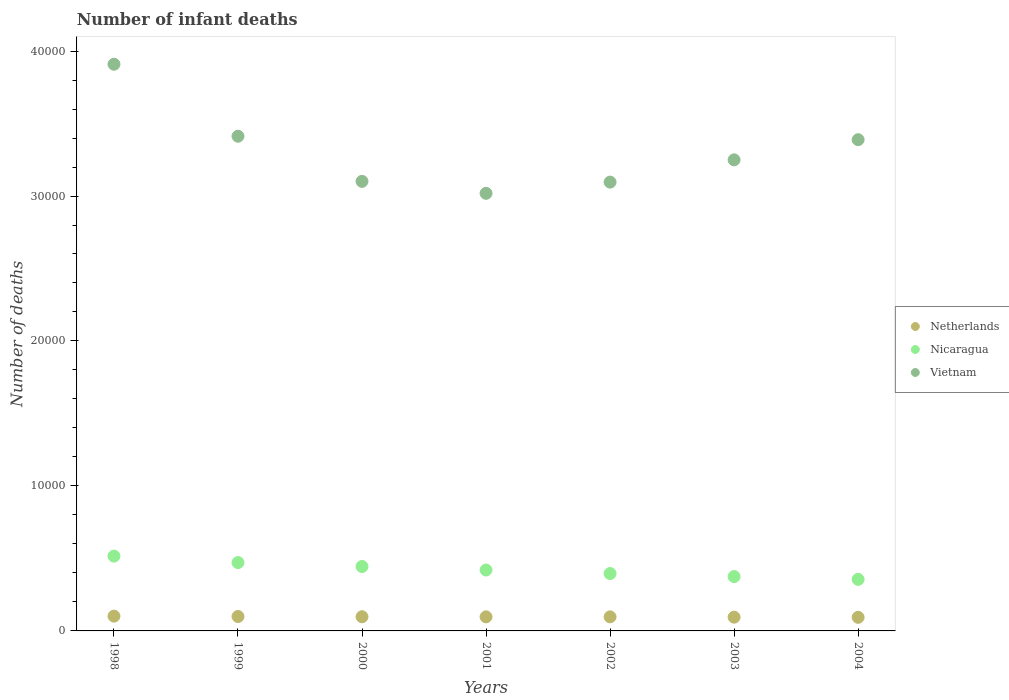How many different coloured dotlines are there?
Give a very brief answer. 3. Is the number of dotlines equal to the number of legend labels?
Your answer should be very brief. Yes. What is the number of infant deaths in Netherlands in 1998?
Your answer should be very brief. 1019. Across all years, what is the maximum number of infant deaths in Vietnam?
Provide a short and direct response. 3.91e+04. Across all years, what is the minimum number of infant deaths in Netherlands?
Offer a very short reply. 938. What is the total number of infant deaths in Nicaragua in the graph?
Your answer should be compact. 2.98e+04. What is the difference between the number of infant deaths in Vietnam in 2001 and that in 2003?
Give a very brief answer. -2308. What is the difference between the number of infant deaths in Netherlands in 1998 and the number of infant deaths in Nicaragua in 2004?
Make the answer very short. -2537. What is the average number of infant deaths in Netherlands per year?
Make the answer very short. 974.14. In the year 2002, what is the difference between the number of infant deaths in Vietnam and number of infant deaths in Nicaragua?
Your answer should be very brief. 2.70e+04. What is the ratio of the number of infant deaths in Nicaragua in 1998 to that in 2001?
Provide a short and direct response. 1.23. Is the number of infant deaths in Vietnam in 1999 less than that in 2003?
Your answer should be compact. No. What is the difference between the highest and the second highest number of infant deaths in Vietnam?
Offer a terse response. 4966. What is the difference between the highest and the lowest number of infant deaths in Vietnam?
Your answer should be very brief. 8904. Is the sum of the number of infant deaths in Nicaragua in 2001 and 2002 greater than the maximum number of infant deaths in Netherlands across all years?
Your response must be concise. Yes. Does the number of infant deaths in Vietnam monotonically increase over the years?
Your answer should be compact. No. Is the number of infant deaths in Nicaragua strictly less than the number of infant deaths in Vietnam over the years?
Make the answer very short. Yes. Are the values on the major ticks of Y-axis written in scientific E-notation?
Provide a succinct answer. No. Does the graph contain grids?
Make the answer very short. No. Where does the legend appear in the graph?
Make the answer very short. Center right. What is the title of the graph?
Provide a short and direct response. Number of infant deaths. What is the label or title of the X-axis?
Make the answer very short. Years. What is the label or title of the Y-axis?
Offer a terse response. Number of deaths. What is the Number of deaths of Netherlands in 1998?
Make the answer very short. 1019. What is the Number of deaths of Nicaragua in 1998?
Provide a short and direct response. 5161. What is the Number of deaths of Vietnam in 1998?
Your answer should be very brief. 3.91e+04. What is the Number of deaths of Netherlands in 1999?
Provide a succinct answer. 995. What is the Number of deaths of Nicaragua in 1999?
Keep it short and to the point. 4716. What is the Number of deaths in Vietnam in 1999?
Your answer should be very brief. 3.41e+04. What is the Number of deaths of Netherlands in 2000?
Your response must be concise. 978. What is the Number of deaths in Nicaragua in 2000?
Ensure brevity in your answer.  4444. What is the Number of deaths in Vietnam in 2000?
Keep it short and to the point. 3.10e+04. What is the Number of deaths of Netherlands in 2001?
Provide a succinct answer. 971. What is the Number of deaths in Nicaragua in 2001?
Provide a succinct answer. 4201. What is the Number of deaths in Vietnam in 2001?
Make the answer very short. 3.02e+04. What is the Number of deaths of Netherlands in 2002?
Your response must be concise. 970. What is the Number of deaths in Nicaragua in 2002?
Your answer should be compact. 3958. What is the Number of deaths of Vietnam in 2002?
Provide a succinct answer. 3.10e+04. What is the Number of deaths in Netherlands in 2003?
Offer a very short reply. 948. What is the Number of deaths of Nicaragua in 2003?
Offer a very short reply. 3749. What is the Number of deaths of Vietnam in 2003?
Your answer should be compact. 3.25e+04. What is the Number of deaths of Netherlands in 2004?
Provide a succinct answer. 938. What is the Number of deaths in Nicaragua in 2004?
Offer a very short reply. 3556. What is the Number of deaths in Vietnam in 2004?
Offer a very short reply. 3.39e+04. Across all years, what is the maximum Number of deaths in Netherlands?
Keep it short and to the point. 1019. Across all years, what is the maximum Number of deaths of Nicaragua?
Offer a terse response. 5161. Across all years, what is the maximum Number of deaths of Vietnam?
Your answer should be compact. 3.91e+04. Across all years, what is the minimum Number of deaths of Netherlands?
Provide a succinct answer. 938. Across all years, what is the minimum Number of deaths of Nicaragua?
Your answer should be compact. 3556. Across all years, what is the minimum Number of deaths of Vietnam?
Your response must be concise. 3.02e+04. What is the total Number of deaths in Netherlands in the graph?
Offer a terse response. 6819. What is the total Number of deaths in Nicaragua in the graph?
Provide a short and direct response. 2.98e+04. What is the total Number of deaths in Vietnam in the graph?
Give a very brief answer. 2.32e+05. What is the difference between the Number of deaths of Netherlands in 1998 and that in 1999?
Ensure brevity in your answer.  24. What is the difference between the Number of deaths in Nicaragua in 1998 and that in 1999?
Provide a succinct answer. 445. What is the difference between the Number of deaths of Vietnam in 1998 and that in 1999?
Keep it short and to the point. 4966. What is the difference between the Number of deaths of Netherlands in 1998 and that in 2000?
Keep it short and to the point. 41. What is the difference between the Number of deaths in Nicaragua in 1998 and that in 2000?
Make the answer very short. 717. What is the difference between the Number of deaths in Vietnam in 1998 and that in 2000?
Give a very brief answer. 8080. What is the difference between the Number of deaths of Netherlands in 1998 and that in 2001?
Offer a very short reply. 48. What is the difference between the Number of deaths of Nicaragua in 1998 and that in 2001?
Your answer should be compact. 960. What is the difference between the Number of deaths in Vietnam in 1998 and that in 2001?
Your response must be concise. 8904. What is the difference between the Number of deaths in Netherlands in 1998 and that in 2002?
Your response must be concise. 49. What is the difference between the Number of deaths in Nicaragua in 1998 and that in 2002?
Your response must be concise. 1203. What is the difference between the Number of deaths of Vietnam in 1998 and that in 2002?
Offer a very short reply. 8132. What is the difference between the Number of deaths in Nicaragua in 1998 and that in 2003?
Keep it short and to the point. 1412. What is the difference between the Number of deaths in Vietnam in 1998 and that in 2003?
Provide a succinct answer. 6596. What is the difference between the Number of deaths of Nicaragua in 1998 and that in 2004?
Provide a short and direct response. 1605. What is the difference between the Number of deaths of Vietnam in 1998 and that in 2004?
Your answer should be compact. 5205. What is the difference between the Number of deaths of Netherlands in 1999 and that in 2000?
Offer a terse response. 17. What is the difference between the Number of deaths in Nicaragua in 1999 and that in 2000?
Your answer should be compact. 272. What is the difference between the Number of deaths in Vietnam in 1999 and that in 2000?
Provide a short and direct response. 3114. What is the difference between the Number of deaths in Nicaragua in 1999 and that in 2001?
Your response must be concise. 515. What is the difference between the Number of deaths of Vietnam in 1999 and that in 2001?
Ensure brevity in your answer.  3938. What is the difference between the Number of deaths of Nicaragua in 1999 and that in 2002?
Provide a succinct answer. 758. What is the difference between the Number of deaths in Vietnam in 1999 and that in 2002?
Ensure brevity in your answer.  3166. What is the difference between the Number of deaths in Nicaragua in 1999 and that in 2003?
Provide a short and direct response. 967. What is the difference between the Number of deaths in Vietnam in 1999 and that in 2003?
Your response must be concise. 1630. What is the difference between the Number of deaths of Netherlands in 1999 and that in 2004?
Offer a very short reply. 57. What is the difference between the Number of deaths of Nicaragua in 1999 and that in 2004?
Your response must be concise. 1160. What is the difference between the Number of deaths of Vietnam in 1999 and that in 2004?
Your response must be concise. 239. What is the difference between the Number of deaths of Netherlands in 2000 and that in 2001?
Offer a terse response. 7. What is the difference between the Number of deaths of Nicaragua in 2000 and that in 2001?
Your answer should be very brief. 243. What is the difference between the Number of deaths of Vietnam in 2000 and that in 2001?
Your answer should be very brief. 824. What is the difference between the Number of deaths in Nicaragua in 2000 and that in 2002?
Offer a terse response. 486. What is the difference between the Number of deaths of Netherlands in 2000 and that in 2003?
Provide a succinct answer. 30. What is the difference between the Number of deaths in Nicaragua in 2000 and that in 2003?
Your answer should be compact. 695. What is the difference between the Number of deaths in Vietnam in 2000 and that in 2003?
Give a very brief answer. -1484. What is the difference between the Number of deaths of Netherlands in 2000 and that in 2004?
Ensure brevity in your answer.  40. What is the difference between the Number of deaths of Nicaragua in 2000 and that in 2004?
Offer a terse response. 888. What is the difference between the Number of deaths in Vietnam in 2000 and that in 2004?
Your answer should be very brief. -2875. What is the difference between the Number of deaths of Netherlands in 2001 and that in 2002?
Provide a short and direct response. 1. What is the difference between the Number of deaths of Nicaragua in 2001 and that in 2002?
Offer a very short reply. 243. What is the difference between the Number of deaths in Vietnam in 2001 and that in 2002?
Offer a very short reply. -772. What is the difference between the Number of deaths of Netherlands in 2001 and that in 2003?
Your answer should be very brief. 23. What is the difference between the Number of deaths in Nicaragua in 2001 and that in 2003?
Offer a very short reply. 452. What is the difference between the Number of deaths of Vietnam in 2001 and that in 2003?
Provide a succinct answer. -2308. What is the difference between the Number of deaths of Netherlands in 2001 and that in 2004?
Give a very brief answer. 33. What is the difference between the Number of deaths of Nicaragua in 2001 and that in 2004?
Keep it short and to the point. 645. What is the difference between the Number of deaths of Vietnam in 2001 and that in 2004?
Keep it short and to the point. -3699. What is the difference between the Number of deaths in Netherlands in 2002 and that in 2003?
Provide a succinct answer. 22. What is the difference between the Number of deaths in Nicaragua in 2002 and that in 2003?
Ensure brevity in your answer.  209. What is the difference between the Number of deaths of Vietnam in 2002 and that in 2003?
Make the answer very short. -1536. What is the difference between the Number of deaths of Nicaragua in 2002 and that in 2004?
Offer a very short reply. 402. What is the difference between the Number of deaths of Vietnam in 2002 and that in 2004?
Make the answer very short. -2927. What is the difference between the Number of deaths in Netherlands in 2003 and that in 2004?
Your response must be concise. 10. What is the difference between the Number of deaths in Nicaragua in 2003 and that in 2004?
Keep it short and to the point. 193. What is the difference between the Number of deaths in Vietnam in 2003 and that in 2004?
Provide a succinct answer. -1391. What is the difference between the Number of deaths of Netherlands in 1998 and the Number of deaths of Nicaragua in 1999?
Ensure brevity in your answer.  -3697. What is the difference between the Number of deaths in Netherlands in 1998 and the Number of deaths in Vietnam in 1999?
Provide a succinct answer. -3.31e+04. What is the difference between the Number of deaths of Nicaragua in 1998 and the Number of deaths of Vietnam in 1999?
Your response must be concise. -2.90e+04. What is the difference between the Number of deaths in Netherlands in 1998 and the Number of deaths in Nicaragua in 2000?
Keep it short and to the point. -3425. What is the difference between the Number of deaths of Netherlands in 1998 and the Number of deaths of Vietnam in 2000?
Keep it short and to the point. -3.00e+04. What is the difference between the Number of deaths in Nicaragua in 1998 and the Number of deaths in Vietnam in 2000?
Your answer should be very brief. -2.58e+04. What is the difference between the Number of deaths of Netherlands in 1998 and the Number of deaths of Nicaragua in 2001?
Provide a short and direct response. -3182. What is the difference between the Number of deaths of Netherlands in 1998 and the Number of deaths of Vietnam in 2001?
Ensure brevity in your answer.  -2.92e+04. What is the difference between the Number of deaths of Nicaragua in 1998 and the Number of deaths of Vietnam in 2001?
Make the answer very short. -2.50e+04. What is the difference between the Number of deaths of Netherlands in 1998 and the Number of deaths of Nicaragua in 2002?
Your answer should be compact. -2939. What is the difference between the Number of deaths of Netherlands in 1998 and the Number of deaths of Vietnam in 2002?
Offer a terse response. -2.99e+04. What is the difference between the Number of deaths in Nicaragua in 1998 and the Number of deaths in Vietnam in 2002?
Offer a terse response. -2.58e+04. What is the difference between the Number of deaths in Netherlands in 1998 and the Number of deaths in Nicaragua in 2003?
Keep it short and to the point. -2730. What is the difference between the Number of deaths of Netherlands in 1998 and the Number of deaths of Vietnam in 2003?
Your response must be concise. -3.15e+04. What is the difference between the Number of deaths in Nicaragua in 1998 and the Number of deaths in Vietnam in 2003?
Offer a terse response. -2.73e+04. What is the difference between the Number of deaths in Netherlands in 1998 and the Number of deaths in Nicaragua in 2004?
Make the answer very short. -2537. What is the difference between the Number of deaths in Netherlands in 1998 and the Number of deaths in Vietnam in 2004?
Ensure brevity in your answer.  -3.29e+04. What is the difference between the Number of deaths of Nicaragua in 1998 and the Number of deaths of Vietnam in 2004?
Offer a terse response. -2.87e+04. What is the difference between the Number of deaths of Netherlands in 1999 and the Number of deaths of Nicaragua in 2000?
Provide a succinct answer. -3449. What is the difference between the Number of deaths of Netherlands in 1999 and the Number of deaths of Vietnam in 2000?
Make the answer very short. -3.00e+04. What is the difference between the Number of deaths in Nicaragua in 1999 and the Number of deaths in Vietnam in 2000?
Make the answer very short. -2.63e+04. What is the difference between the Number of deaths in Netherlands in 1999 and the Number of deaths in Nicaragua in 2001?
Your answer should be very brief. -3206. What is the difference between the Number of deaths in Netherlands in 1999 and the Number of deaths in Vietnam in 2001?
Your answer should be compact. -2.92e+04. What is the difference between the Number of deaths in Nicaragua in 1999 and the Number of deaths in Vietnam in 2001?
Your response must be concise. -2.55e+04. What is the difference between the Number of deaths of Netherlands in 1999 and the Number of deaths of Nicaragua in 2002?
Provide a succinct answer. -2963. What is the difference between the Number of deaths of Netherlands in 1999 and the Number of deaths of Vietnam in 2002?
Keep it short and to the point. -3.00e+04. What is the difference between the Number of deaths of Nicaragua in 1999 and the Number of deaths of Vietnam in 2002?
Provide a succinct answer. -2.62e+04. What is the difference between the Number of deaths of Netherlands in 1999 and the Number of deaths of Nicaragua in 2003?
Your response must be concise. -2754. What is the difference between the Number of deaths of Netherlands in 1999 and the Number of deaths of Vietnam in 2003?
Keep it short and to the point. -3.15e+04. What is the difference between the Number of deaths in Nicaragua in 1999 and the Number of deaths in Vietnam in 2003?
Your response must be concise. -2.78e+04. What is the difference between the Number of deaths of Netherlands in 1999 and the Number of deaths of Nicaragua in 2004?
Your answer should be compact. -2561. What is the difference between the Number of deaths in Netherlands in 1999 and the Number of deaths in Vietnam in 2004?
Offer a very short reply. -3.29e+04. What is the difference between the Number of deaths of Nicaragua in 1999 and the Number of deaths of Vietnam in 2004?
Offer a terse response. -2.92e+04. What is the difference between the Number of deaths in Netherlands in 2000 and the Number of deaths in Nicaragua in 2001?
Your response must be concise. -3223. What is the difference between the Number of deaths in Netherlands in 2000 and the Number of deaths in Vietnam in 2001?
Make the answer very short. -2.92e+04. What is the difference between the Number of deaths in Nicaragua in 2000 and the Number of deaths in Vietnam in 2001?
Offer a terse response. -2.57e+04. What is the difference between the Number of deaths of Netherlands in 2000 and the Number of deaths of Nicaragua in 2002?
Give a very brief answer. -2980. What is the difference between the Number of deaths of Netherlands in 2000 and the Number of deaths of Vietnam in 2002?
Keep it short and to the point. -3.00e+04. What is the difference between the Number of deaths in Nicaragua in 2000 and the Number of deaths in Vietnam in 2002?
Provide a succinct answer. -2.65e+04. What is the difference between the Number of deaths of Netherlands in 2000 and the Number of deaths of Nicaragua in 2003?
Make the answer very short. -2771. What is the difference between the Number of deaths of Netherlands in 2000 and the Number of deaths of Vietnam in 2003?
Your response must be concise. -3.15e+04. What is the difference between the Number of deaths in Nicaragua in 2000 and the Number of deaths in Vietnam in 2003?
Your response must be concise. -2.80e+04. What is the difference between the Number of deaths of Netherlands in 2000 and the Number of deaths of Nicaragua in 2004?
Make the answer very short. -2578. What is the difference between the Number of deaths in Netherlands in 2000 and the Number of deaths in Vietnam in 2004?
Give a very brief answer. -3.29e+04. What is the difference between the Number of deaths in Nicaragua in 2000 and the Number of deaths in Vietnam in 2004?
Provide a short and direct response. -2.94e+04. What is the difference between the Number of deaths in Netherlands in 2001 and the Number of deaths in Nicaragua in 2002?
Make the answer very short. -2987. What is the difference between the Number of deaths in Netherlands in 2001 and the Number of deaths in Vietnam in 2002?
Provide a short and direct response. -3.00e+04. What is the difference between the Number of deaths of Nicaragua in 2001 and the Number of deaths of Vietnam in 2002?
Ensure brevity in your answer.  -2.68e+04. What is the difference between the Number of deaths of Netherlands in 2001 and the Number of deaths of Nicaragua in 2003?
Provide a short and direct response. -2778. What is the difference between the Number of deaths of Netherlands in 2001 and the Number of deaths of Vietnam in 2003?
Make the answer very short. -3.15e+04. What is the difference between the Number of deaths in Nicaragua in 2001 and the Number of deaths in Vietnam in 2003?
Offer a terse response. -2.83e+04. What is the difference between the Number of deaths in Netherlands in 2001 and the Number of deaths in Nicaragua in 2004?
Your response must be concise. -2585. What is the difference between the Number of deaths in Netherlands in 2001 and the Number of deaths in Vietnam in 2004?
Make the answer very short. -3.29e+04. What is the difference between the Number of deaths in Nicaragua in 2001 and the Number of deaths in Vietnam in 2004?
Your response must be concise. -2.97e+04. What is the difference between the Number of deaths in Netherlands in 2002 and the Number of deaths in Nicaragua in 2003?
Keep it short and to the point. -2779. What is the difference between the Number of deaths of Netherlands in 2002 and the Number of deaths of Vietnam in 2003?
Ensure brevity in your answer.  -3.15e+04. What is the difference between the Number of deaths of Nicaragua in 2002 and the Number of deaths of Vietnam in 2003?
Provide a short and direct response. -2.85e+04. What is the difference between the Number of deaths of Netherlands in 2002 and the Number of deaths of Nicaragua in 2004?
Keep it short and to the point. -2586. What is the difference between the Number of deaths in Netherlands in 2002 and the Number of deaths in Vietnam in 2004?
Ensure brevity in your answer.  -3.29e+04. What is the difference between the Number of deaths in Nicaragua in 2002 and the Number of deaths in Vietnam in 2004?
Give a very brief answer. -2.99e+04. What is the difference between the Number of deaths of Netherlands in 2003 and the Number of deaths of Nicaragua in 2004?
Offer a terse response. -2608. What is the difference between the Number of deaths of Netherlands in 2003 and the Number of deaths of Vietnam in 2004?
Provide a short and direct response. -3.29e+04. What is the difference between the Number of deaths in Nicaragua in 2003 and the Number of deaths in Vietnam in 2004?
Provide a succinct answer. -3.01e+04. What is the average Number of deaths of Netherlands per year?
Ensure brevity in your answer.  974.14. What is the average Number of deaths of Nicaragua per year?
Offer a very short reply. 4255. What is the average Number of deaths of Vietnam per year?
Provide a succinct answer. 3.31e+04. In the year 1998, what is the difference between the Number of deaths in Netherlands and Number of deaths in Nicaragua?
Provide a short and direct response. -4142. In the year 1998, what is the difference between the Number of deaths of Netherlands and Number of deaths of Vietnam?
Your answer should be very brief. -3.81e+04. In the year 1998, what is the difference between the Number of deaths of Nicaragua and Number of deaths of Vietnam?
Provide a succinct answer. -3.39e+04. In the year 1999, what is the difference between the Number of deaths in Netherlands and Number of deaths in Nicaragua?
Offer a very short reply. -3721. In the year 1999, what is the difference between the Number of deaths of Netherlands and Number of deaths of Vietnam?
Give a very brief answer. -3.31e+04. In the year 1999, what is the difference between the Number of deaths in Nicaragua and Number of deaths in Vietnam?
Offer a very short reply. -2.94e+04. In the year 2000, what is the difference between the Number of deaths of Netherlands and Number of deaths of Nicaragua?
Your answer should be compact. -3466. In the year 2000, what is the difference between the Number of deaths of Netherlands and Number of deaths of Vietnam?
Provide a succinct answer. -3.00e+04. In the year 2000, what is the difference between the Number of deaths in Nicaragua and Number of deaths in Vietnam?
Give a very brief answer. -2.66e+04. In the year 2001, what is the difference between the Number of deaths in Netherlands and Number of deaths in Nicaragua?
Ensure brevity in your answer.  -3230. In the year 2001, what is the difference between the Number of deaths in Netherlands and Number of deaths in Vietnam?
Provide a short and direct response. -2.92e+04. In the year 2001, what is the difference between the Number of deaths of Nicaragua and Number of deaths of Vietnam?
Offer a very short reply. -2.60e+04. In the year 2002, what is the difference between the Number of deaths of Netherlands and Number of deaths of Nicaragua?
Your answer should be very brief. -2988. In the year 2002, what is the difference between the Number of deaths in Netherlands and Number of deaths in Vietnam?
Offer a terse response. -3.00e+04. In the year 2002, what is the difference between the Number of deaths of Nicaragua and Number of deaths of Vietnam?
Provide a succinct answer. -2.70e+04. In the year 2003, what is the difference between the Number of deaths in Netherlands and Number of deaths in Nicaragua?
Give a very brief answer. -2801. In the year 2003, what is the difference between the Number of deaths of Netherlands and Number of deaths of Vietnam?
Offer a terse response. -3.15e+04. In the year 2003, what is the difference between the Number of deaths in Nicaragua and Number of deaths in Vietnam?
Provide a short and direct response. -2.87e+04. In the year 2004, what is the difference between the Number of deaths in Netherlands and Number of deaths in Nicaragua?
Your answer should be compact. -2618. In the year 2004, what is the difference between the Number of deaths of Netherlands and Number of deaths of Vietnam?
Your answer should be very brief. -3.29e+04. In the year 2004, what is the difference between the Number of deaths in Nicaragua and Number of deaths in Vietnam?
Keep it short and to the point. -3.03e+04. What is the ratio of the Number of deaths of Netherlands in 1998 to that in 1999?
Your answer should be compact. 1.02. What is the ratio of the Number of deaths in Nicaragua in 1998 to that in 1999?
Your response must be concise. 1.09. What is the ratio of the Number of deaths in Vietnam in 1998 to that in 1999?
Your answer should be compact. 1.15. What is the ratio of the Number of deaths in Netherlands in 1998 to that in 2000?
Offer a very short reply. 1.04. What is the ratio of the Number of deaths in Nicaragua in 1998 to that in 2000?
Offer a very short reply. 1.16. What is the ratio of the Number of deaths in Vietnam in 1998 to that in 2000?
Keep it short and to the point. 1.26. What is the ratio of the Number of deaths of Netherlands in 1998 to that in 2001?
Give a very brief answer. 1.05. What is the ratio of the Number of deaths in Nicaragua in 1998 to that in 2001?
Keep it short and to the point. 1.23. What is the ratio of the Number of deaths in Vietnam in 1998 to that in 2001?
Provide a succinct answer. 1.29. What is the ratio of the Number of deaths of Netherlands in 1998 to that in 2002?
Offer a very short reply. 1.05. What is the ratio of the Number of deaths of Nicaragua in 1998 to that in 2002?
Provide a succinct answer. 1.3. What is the ratio of the Number of deaths in Vietnam in 1998 to that in 2002?
Offer a very short reply. 1.26. What is the ratio of the Number of deaths in Netherlands in 1998 to that in 2003?
Give a very brief answer. 1.07. What is the ratio of the Number of deaths of Nicaragua in 1998 to that in 2003?
Offer a terse response. 1.38. What is the ratio of the Number of deaths in Vietnam in 1998 to that in 2003?
Ensure brevity in your answer.  1.2. What is the ratio of the Number of deaths in Netherlands in 1998 to that in 2004?
Ensure brevity in your answer.  1.09. What is the ratio of the Number of deaths in Nicaragua in 1998 to that in 2004?
Offer a terse response. 1.45. What is the ratio of the Number of deaths in Vietnam in 1998 to that in 2004?
Give a very brief answer. 1.15. What is the ratio of the Number of deaths of Netherlands in 1999 to that in 2000?
Offer a very short reply. 1.02. What is the ratio of the Number of deaths in Nicaragua in 1999 to that in 2000?
Give a very brief answer. 1.06. What is the ratio of the Number of deaths in Vietnam in 1999 to that in 2000?
Ensure brevity in your answer.  1.1. What is the ratio of the Number of deaths in Netherlands in 1999 to that in 2001?
Your answer should be very brief. 1.02. What is the ratio of the Number of deaths of Nicaragua in 1999 to that in 2001?
Keep it short and to the point. 1.12. What is the ratio of the Number of deaths of Vietnam in 1999 to that in 2001?
Make the answer very short. 1.13. What is the ratio of the Number of deaths in Netherlands in 1999 to that in 2002?
Ensure brevity in your answer.  1.03. What is the ratio of the Number of deaths of Nicaragua in 1999 to that in 2002?
Offer a very short reply. 1.19. What is the ratio of the Number of deaths of Vietnam in 1999 to that in 2002?
Ensure brevity in your answer.  1.1. What is the ratio of the Number of deaths of Netherlands in 1999 to that in 2003?
Keep it short and to the point. 1.05. What is the ratio of the Number of deaths in Nicaragua in 1999 to that in 2003?
Give a very brief answer. 1.26. What is the ratio of the Number of deaths in Vietnam in 1999 to that in 2003?
Give a very brief answer. 1.05. What is the ratio of the Number of deaths of Netherlands in 1999 to that in 2004?
Your answer should be very brief. 1.06. What is the ratio of the Number of deaths of Nicaragua in 1999 to that in 2004?
Offer a terse response. 1.33. What is the ratio of the Number of deaths of Vietnam in 1999 to that in 2004?
Give a very brief answer. 1.01. What is the ratio of the Number of deaths in Nicaragua in 2000 to that in 2001?
Your answer should be very brief. 1.06. What is the ratio of the Number of deaths of Vietnam in 2000 to that in 2001?
Provide a short and direct response. 1.03. What is the ratio of the Number of deaths of Netherlands in 2000 to that in 2002?
Ensure brevity in your answer.  1.01. What is the ratio of the Number of deaths of Nicaragua in 2000 to that in 2002?
Offer a terse response. 1.12. What is the ratio of the Number of deaths of Netherlands in 2000 to that in 2003?
Your response must be concise. 1.03. What is the ratio of the Number of deaths in Nicaragua in 2000 to that in 2003?
Give a very brief answer. 1.19. What is the ratio of the Number of deaths of Vietnam in 2000 to that in 2003?
Your answer should be very brief. 0.95. What is the ratio of the Number of deaths of Netherlands in 2000 to that in 2004?
Your response must be concise. 1.04. What is the ratio of the Number of deaths in Nicaragua in 2000 to that in 2004?
Provide a short and direct response. 1.25. What is the ratio of the Number of deaths of Vietnam in 2000 to that in 2004?
Give a very brief answer. 0.92. What is the ratio of the Number of deaths in Netherlands in 2001 to that in 2002?
Offer a very short reply. 1. What is the ratio of the Number of deaths of Nicaragua in 2001 to that in 2002?
Your answer should be very brief. 1.06. What is the ratio of the Number of deaths of Vietnam in 2001 to that in 2002?
Your answer should be very brief. 0.98. What is the ratio of the Number of deaths in Netherlands in 2001 to that in 2003?
Your answer should be compact. 1.02. What is the ratio of the Number of deaths of Nicaragua in 2001 to that in 2003?
Your answer should be very brief. 1.12. What is the ratio of the Number of deaths in Vietnam in 2001 to that in 2003?
Provide a short and direct response. 0.93. What is the ratio of the Number of deaths in Netherlands in 2001 to that in 2004?
Make the answer very short. 1.04. What is the ratio of the Number of deaths of Nicaragua in 2001 to that in 2004?
Make the answer very short. 1.18. What is the ratio of the Number of deaths of Vietnam in 2001 to that in 2004?
Your response must be concise. 0.89. What is the ratio of the Number of deaths of Netherlands in 2002 to that in 2003?
Keep it short and to the point. 1.02. What is the ratio of the Number of deaths of Nicaragua in 2002 to that in 2003?
Keep it short and to the point. 1.06. What is the ratio of the Number of deaths of Vietnam in 2002 to that in 2003?
Make the answer very short. 0.95. What is the ratio of the Number of deaths in Netherlands in 2002 to that in 2004?
Make the answer very short. 1.03. What is the ratio of the Number of deaths of Nicaragua in 2002 to that in 2004?
Your answer should be very brief. 1.11. What is the ratio of the Number of deaths of Vietnam in 2002 to that in 2004?
Offer a terse response. 0.91. What is the ratio of the Number of deaths of Netherlands in 2003 to that in 2004?
Make the answer very short. 1.01. What is the ratio of the Number of deaths in Nicaragua in 2003 to that in 2004?
Your answer should be compact. 1.05. What is the ratio of the Number of deaths of Vietnam in 2003 to that in 2004?
Keep it short and to the point. 0.96. What is the difference between the highest and the second highest Number of deaths in Nicaragua?
Offer a terse response. 445. What is the difference between the highest and the second highest Number of deaths in Vietnam?
Ensure brevity in your answer.  4966. What is the difference between the highest and the lowest Number of deaths of Netherlands?
Give a very brief answer. 81. What is the difference between the highest and the lowest Number of deaths of Nicaragua?
Your answer should be very brief. 1605. What is the difference between the highest and the lowest Number of deaths of Vietnam?
Provide a succinct answer. 8904. 